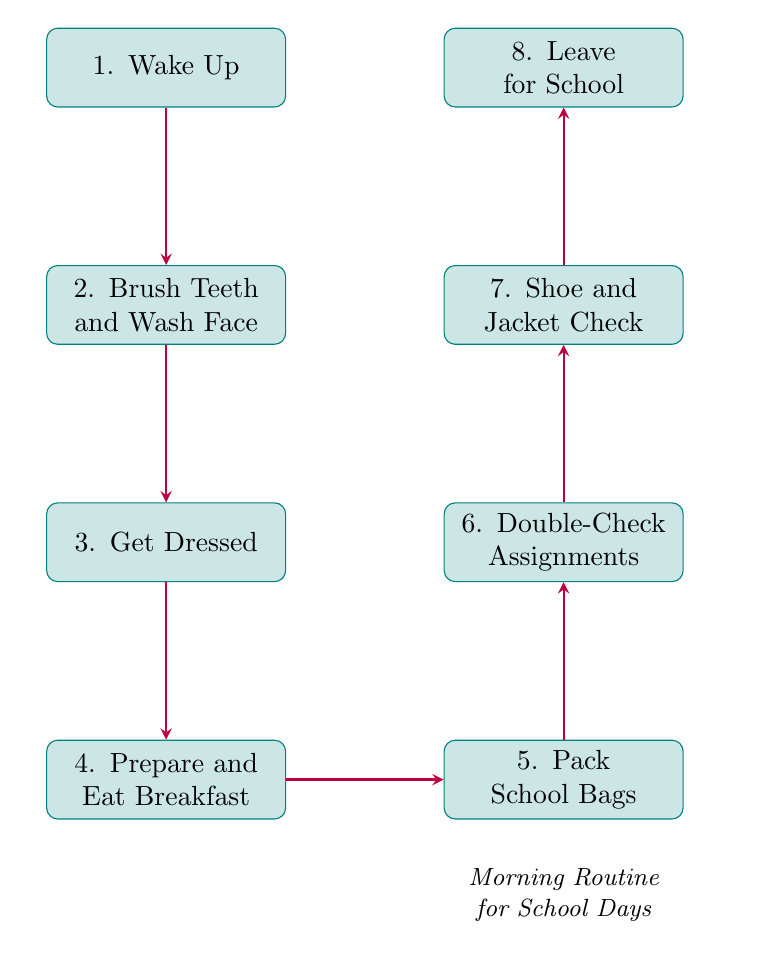What is the first step in the morning routine? The flowchart starts with the node "1. Wake Up," which is the first action that parents and children take in the morning.
Answer: Wake Up How many steps are there in total? The flowchart contains eight steps, listed sequentially from "Wake Up" to "Leave for School."
Answer: Eight What is the last step in the routine? The last action in the flowchart is "8. Leave for School," which indicates that the morning routine concludes with heading out for school.
Answer: Leave for School What activity follows "Prepare and Eat Breakfast"? After the node "4. Prepare and Eat Breakfast," the next step is "5. Pack School Bags," which involves getting school supplies ready.
Answer: Pack School Bags Which step involves checking assignments? The node "6. Double-Check Assignments and Notices" refers specifically to verifying any homework and important notices before heading to school.
Answer: Double-Check Assignments What is required before leaving for school? Before the final step of leaving for school, it is necessary to perform a "7. Shoe and Jacket Check," ensuring proper attire for the weather.
Answer: Shoe and Jacket Check What two tasks are performed simultaneously during breakfast preparation? During the "4. Prepare and Eat Breakfast" stage, the tasks of preparing a healthy breakfast and eating together are completed at the same time.
Answer: Prepare and Eat Breakfast Which node does "Double-Check Assignments and Notices" connect to? The "Double-Check Assignments and Notices" node is directly connected to the "Shoe and Jacket Check" node in the sequence of the routine.
Answer: Shoe and Jacket Check 